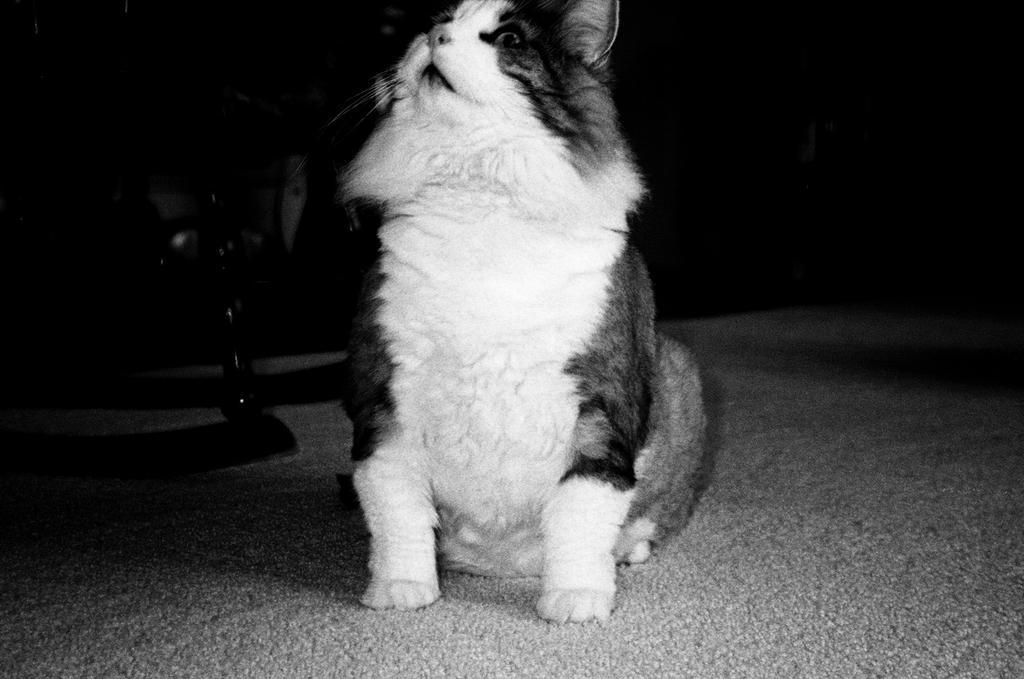How would you summarize this image in a sentence or two? In this picture we can see a cat is seated on the floor. 